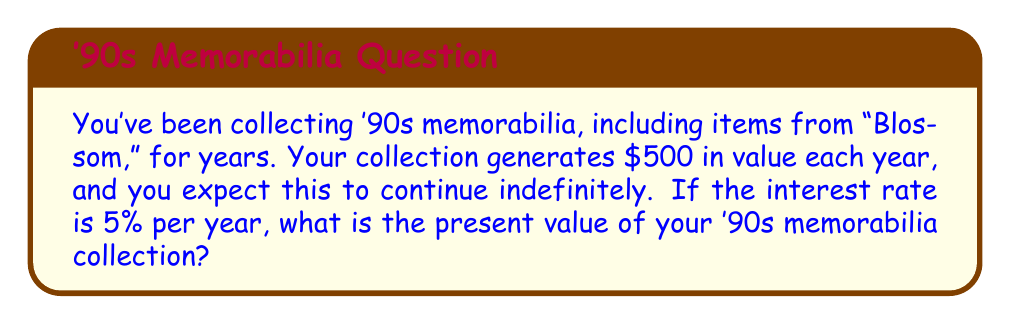Teach me how to tackle this problem. Let's approach this step-by-step using the concept of infinite geometric series:

1) The present value (PV) of an infinite series of equal payments is given by the formula:

   $$ PV = \frac{A}{r} $$

   Where $A$ is the annual payment and $r$ is the interest rate.

2) In this case:
   $A = \$500$ (annual value generated by the collection)
   $r = 0.05$ (5% interest rate)

3) Plugging these values into the formula:

   $$ PV = \frac{\$500}{0.05} $$

4) Calculating:

   $$ PV = \$10,000 $$

This means that the present value of your '90s memorabilia collection, including those awesome "Blossom" items, is equivalent to $10,000 in today's money.

The logic behind this is that $10,000 invested at 5% would generate $500 per year indefinitely, matching the value generated by your collection.
Answer: $10,000 